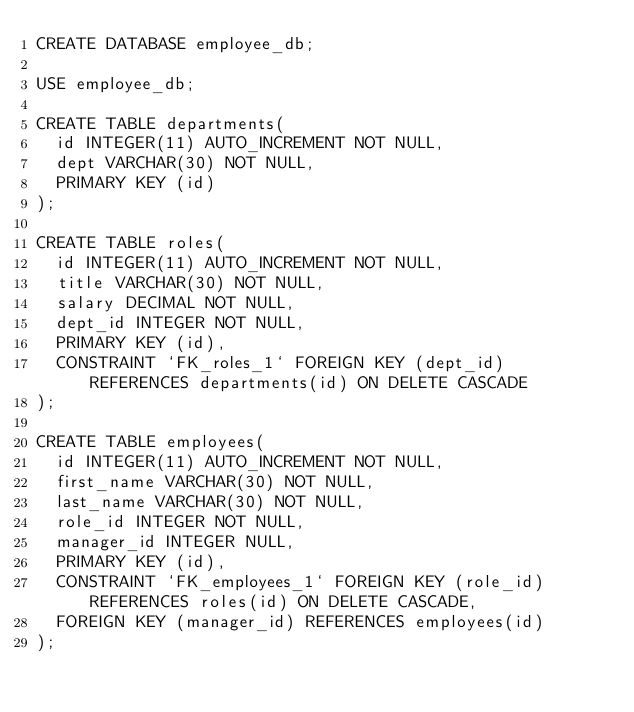<code> <loc_0><loc_0><loc_500><loc_500><_SQL_>CREATE DATABASE employee_db;

USE employee_db;

CREATE TABLE departments(
  id INTEGER(11) AUTO_INCREMENT NOT NULL,
  dept VARCHAR(30) NOT NULL,
  PRIMARY KEY (id)
);

CREATE TABLE roles(
  id INTEGER(11) AUTO_INCREMENT NOT NULL,
  title VARCHAR(30) NOT NULL,
  salary DECIMAL NOT NULL,
  dept_id INTEGER NOT NULL,
  PRIMARY KEY (id),
  CONSTRAINT `FK_roles_1` FOREIGN KEY (dept_id) REFERENCES departments(id) ON DELETE CASCADE
);

CREATE TABLE employees(
  id INTEGER(11) AUTO_INCREMENT NOT NULL,
  first_name VARCHAR(30) NOT NULL,
  last_name VARCHAR(30) NOT NULL,
  role_id INTEGER NOT NULL,
  manager_id INTEGER NULL,
  PRIMARY KEY (id),
  CONSTRAINT `FK_employees_1` FOREIGN KEY (role_id) REFERENCES roles(id) ON DELETE CASCADE,
  FOREIGN KEY (manager_id) REFERENCES employees(id)
);</code> 